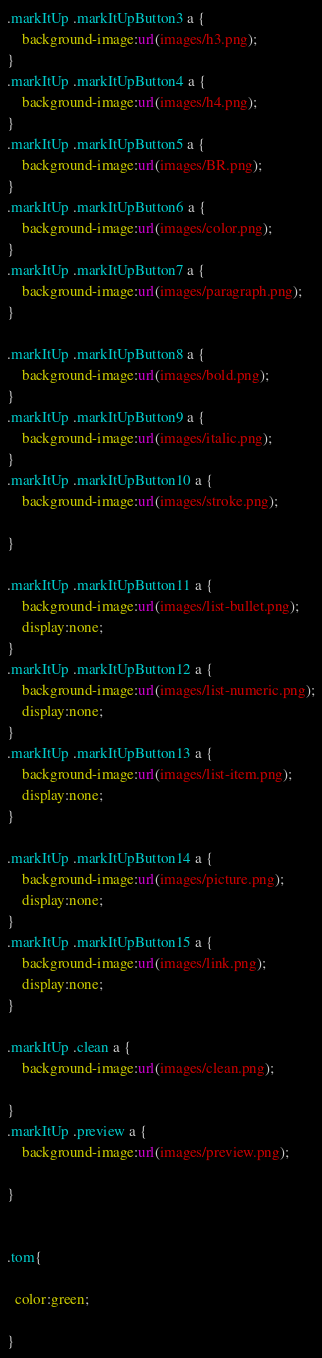Convert code to text. <code><loc_0><loc_0><loc_500><loc_500><_CSS_>.markItUp .markItUpButton3 a {
	background-image:url(images/h3.png); 
}
.markItUp .markItUpButton4 a {
	background-image:url(images/h4.png); 
}
.markItUp .markItUpButton5 a {
	background-image:url(images/BR.png);
}
.markItUp .markItUpButton6 a {
	background-image:url(images/color.png);
}
.markItUp .markItUpButton7 a {
	background-image:url(images/paragraph.png); 
}

.markItUp .markItUpButton8 a {
	background-image:url(images/bold.png);
}
.markItUp .markItUpButton9 a {
	background-image:url(images/italic.png);
}
.markItUp .markItUpButton10 a {
	background-image:url(images/stroke.png);

}

.markItUp .markItUpButton11 a {
	background-image:url(images/list-bullet.png);
    display:none;
}
.markItUp .markItUpButton12 a {
	background-image:url(images/list-numeric.png);
    display:none;
}
.markItUp .markItUpButton13 a {
	background-image:url(images/list-item.png);
    display:none;
}

.markItUp .markItUpButton14 a {
	background-image:url(images/picture.png);
    display:none;
}
.markItUp .markItUpButton15 a {
	background-image:url(images/link.png);
    display:none;
}

.markItUp .clean a {
	background-image:url(images/clean.png);

}
.markItUp .preview a {
	background-image:url(images/preview.png);

}


.tom{

  color:green;

}</code> 